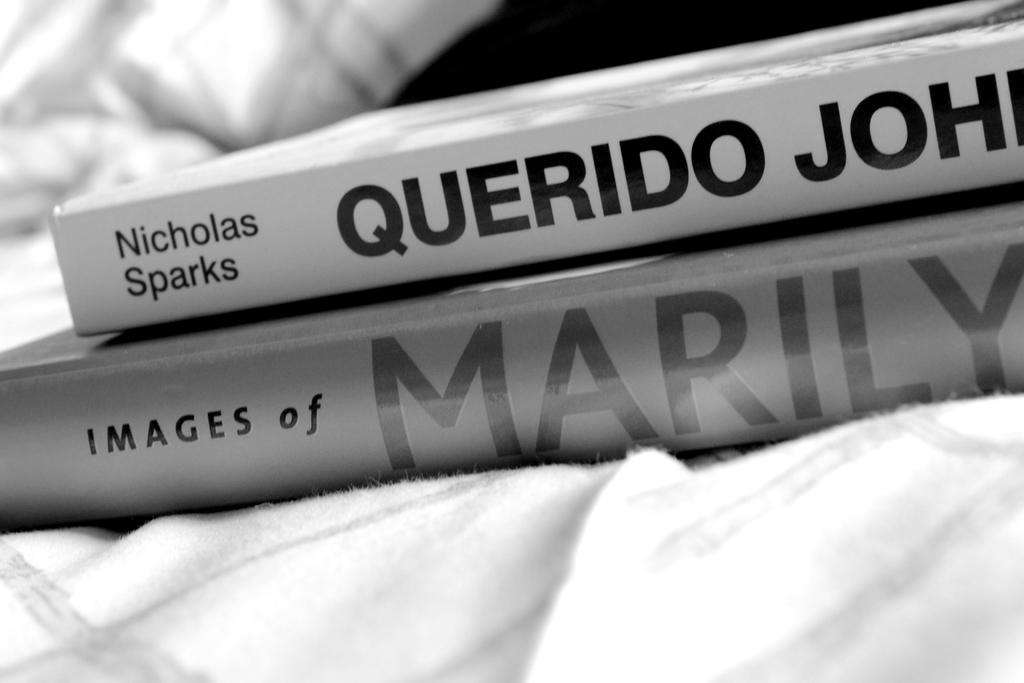<image>
Create a compact narrative representing the image presented. A pile of two books in black and white with one book titled Querido John by Nicholas Sparks and the bottom book is titled Images of Marilyn 